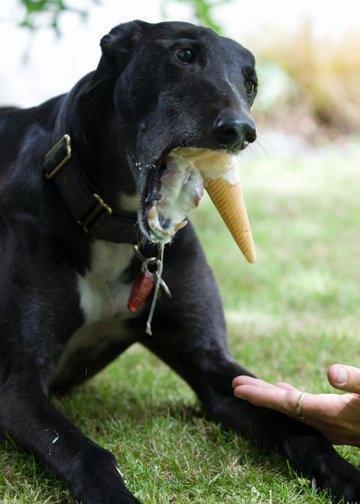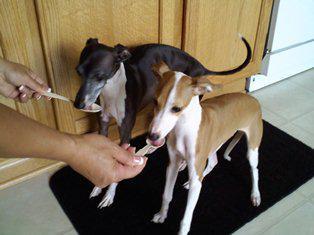The first image is the image on the left, the second image is the image on the right. Analyze the images presented: Is the assertion "At least one of the images includes a dog interacting with an ice cream cone." valid? Answer yes or no. Yes. The first image is the image on the left, the second image is the image on the right. Evaluate the accuracy of this statement regarding the images: "There is two dogs in the right image.". Is it true? Answer yes or no. Yes. 